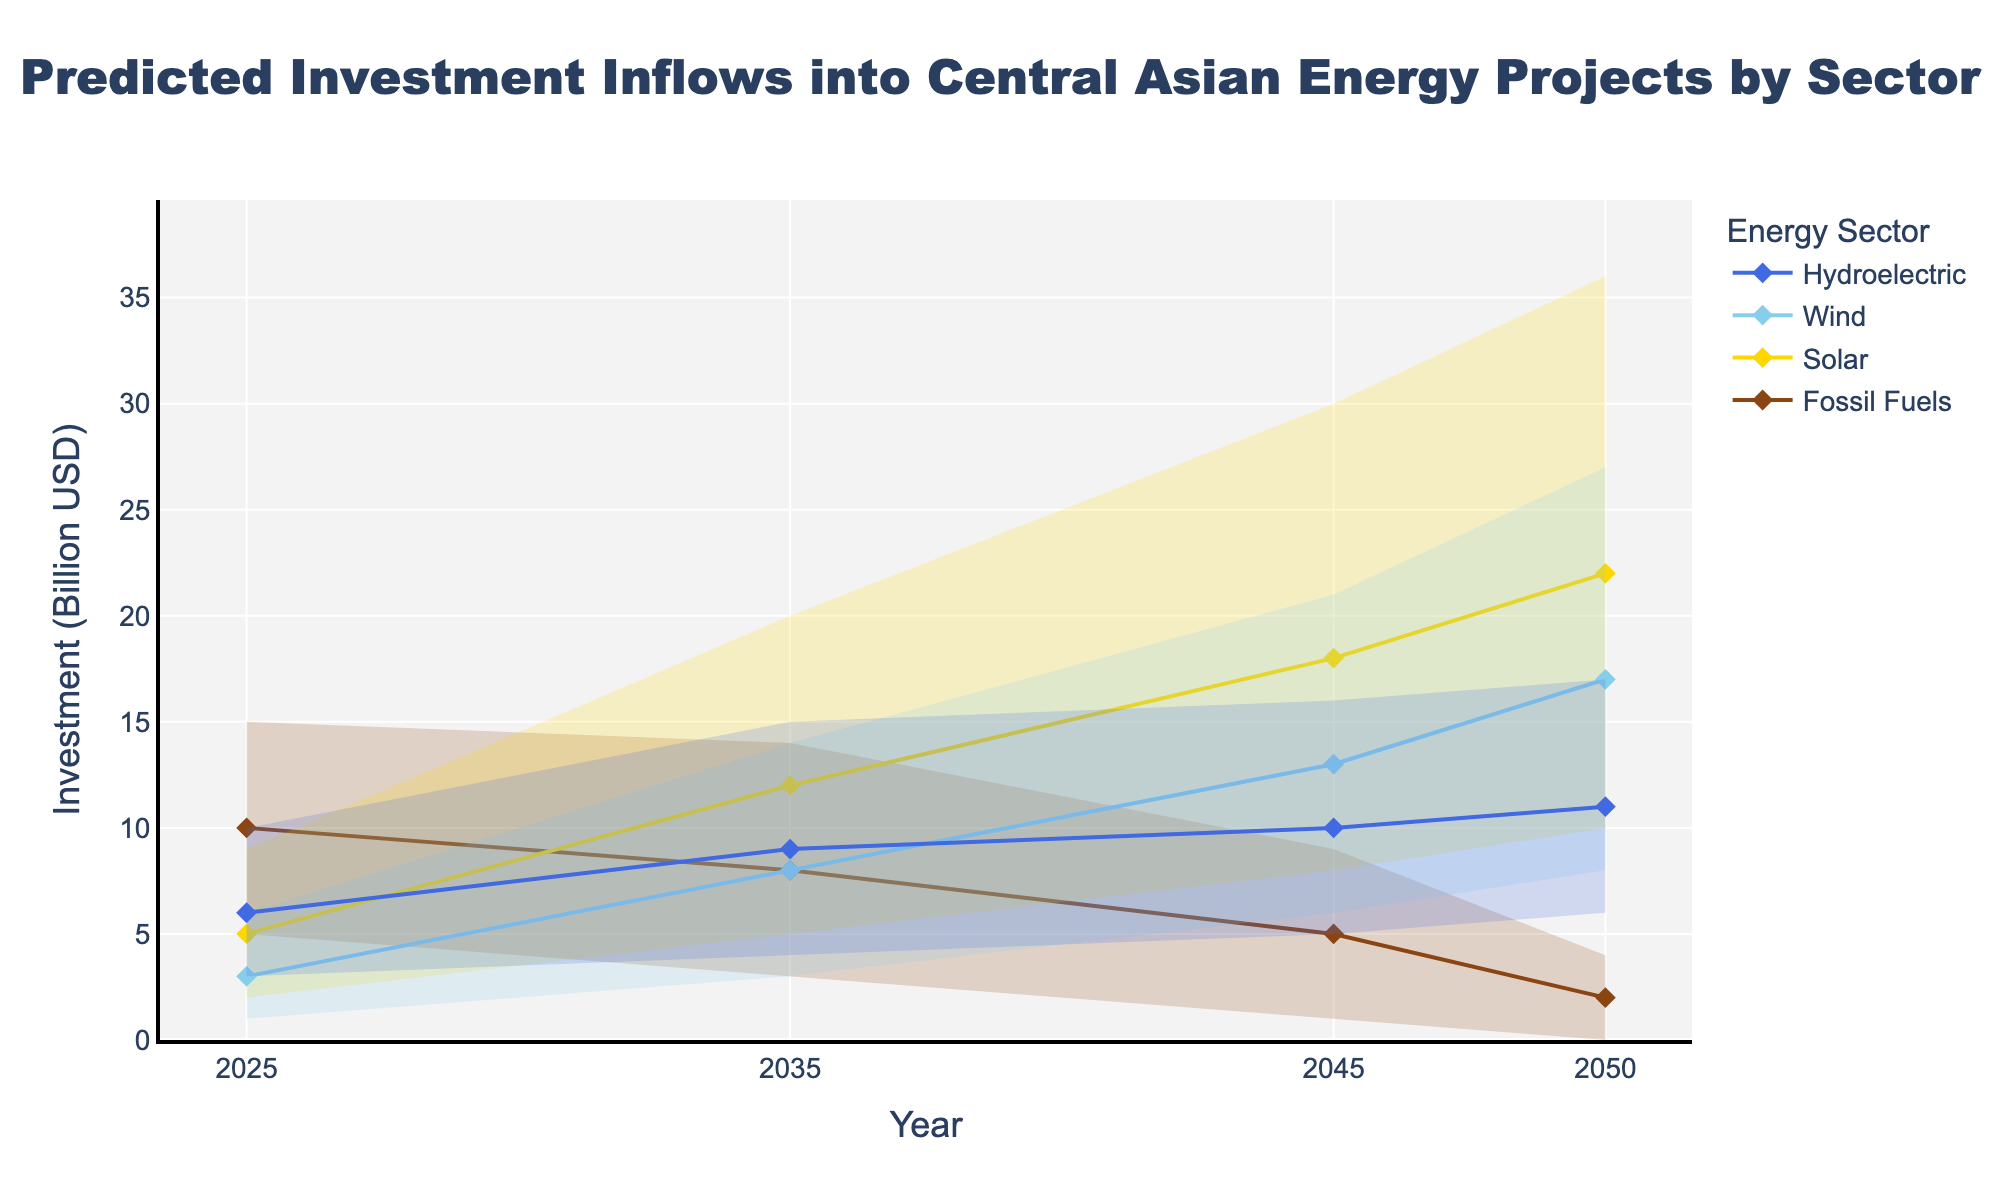what is the y-axis representing in the figure? The y-axis title indicates that it is representing the investment in billion USD.
Answer: Investment in billion USD What year is predicted to have the highest mean investment in solar energy? The mean investment can be read from the 'Mid' trace of each year for the solar sector in the figure; the highest mid value is at 2050.
Answer: 2050 How does the range of predicted investments in wind energy compare between 2025 and 2050? The range is calculated as the difference between the highest and lowest values of each year for the wind sector. In 2025, it ranges from 1 to 6 billion USD, and in 2050, it ranges from 8 to 27 billion USD. The range increases significantly from 2025 to 2050.
Answer: The range increases significantly Which energy sector shows the most significant increase in mean investment from 2025 to 2050? By observing the mid-values (mean investments) from 2025 to 2050, solar energy increases from 5 billion USD in 2025 to 22 billion USD in 2050, showing the most significant growth.
Answer: Solar energy Does any sector see a predicted decrease in their average investment from 2025 to 2050? By comparing the mid-values of each sector between 2025 and 2050: Fossil fuels decrease from 10 billion USD (2025) to 2 billion USD (2050).
Answer: Fossil fuels What is the expected investment range in hydroelectric energy in 2045? From the fan sections for hydroelectric energy in 2045, the lowest value is 5 and the highest value is 16 billion USD, giving an expected range of predictions.
Answer: 5 to 16 billion USD Considering all sectors, which year observes the greatest variability in predictions? Variability can be identified by the width of the fans; larger widths indicate higher variability. In 2050, each sector especially shows broader fan ranges compared to other years.
Answer: 2050 Which sector shows the lowest predicted average investment in 2035? By observing the mid-lines of each sector for 2035, Fossil Fuels show the lowest mean investment of 8 billion USD.
Answer: Fossil fuels 